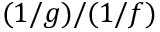<formula> <loc_0><loc_0><loc_500><loc_500>( 1 / g ) / ( 1 / f )</formula> 